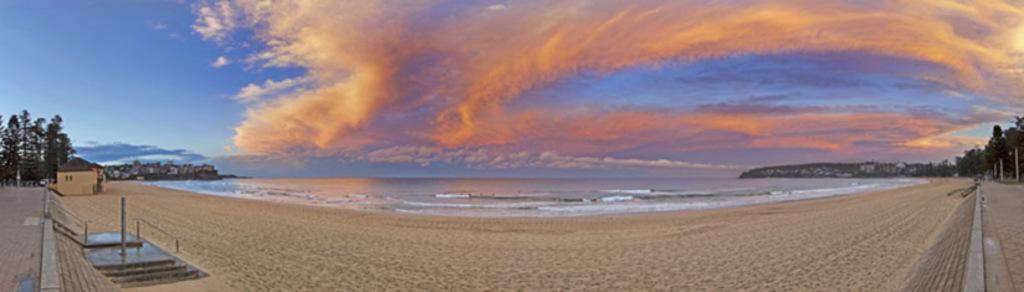Describe this image in one or two sentences. In this picture I can see water. There are buildings, trees, and in the background there is the sky. 